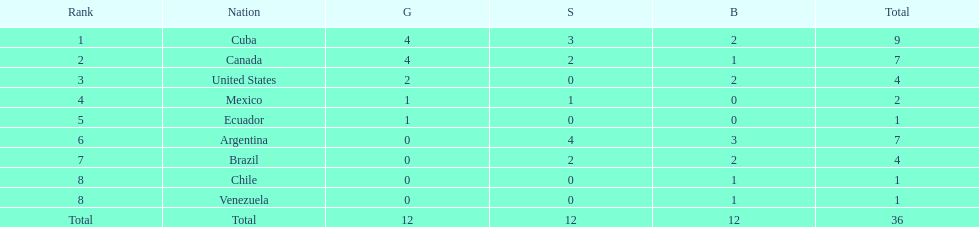What is the total number of nations that did not win gold? 4. 